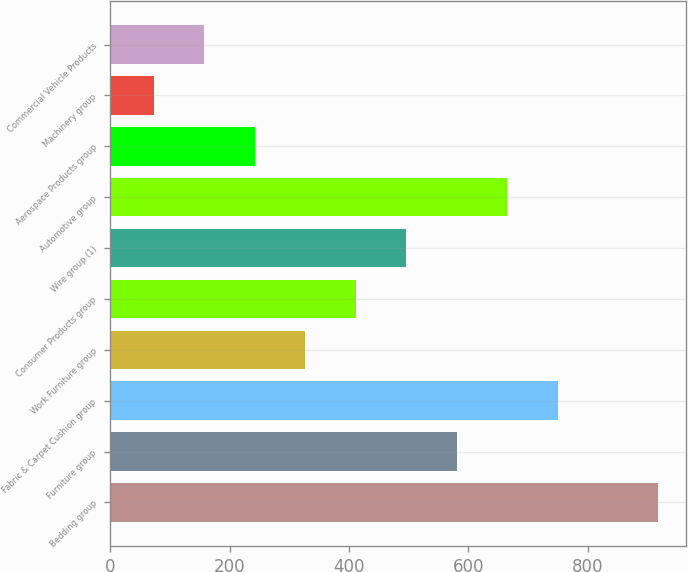<chart> <loc_0><loc_0><loc_500><loc_500><bar_chart><fcel>Bedding group<fcel>Furniture group<fcel>Fabric & Carpet Cushion group<fcel>Work Furniture group<fcel>Consumer Products group<fcel>Wire group (1)<fcel>Automotive group<fcel>Aerospace Products group<fcel>Machinery group<fcel>Commercial Vehicle Products<nl><fcel>918.3<fcel>580.1<fcel>749.2<fcel>326.45<fcel>411<fcel>495.55<fcel>664.65<fcel>241.9<fcel>72.8<fcel>157.35<nl></chart> 